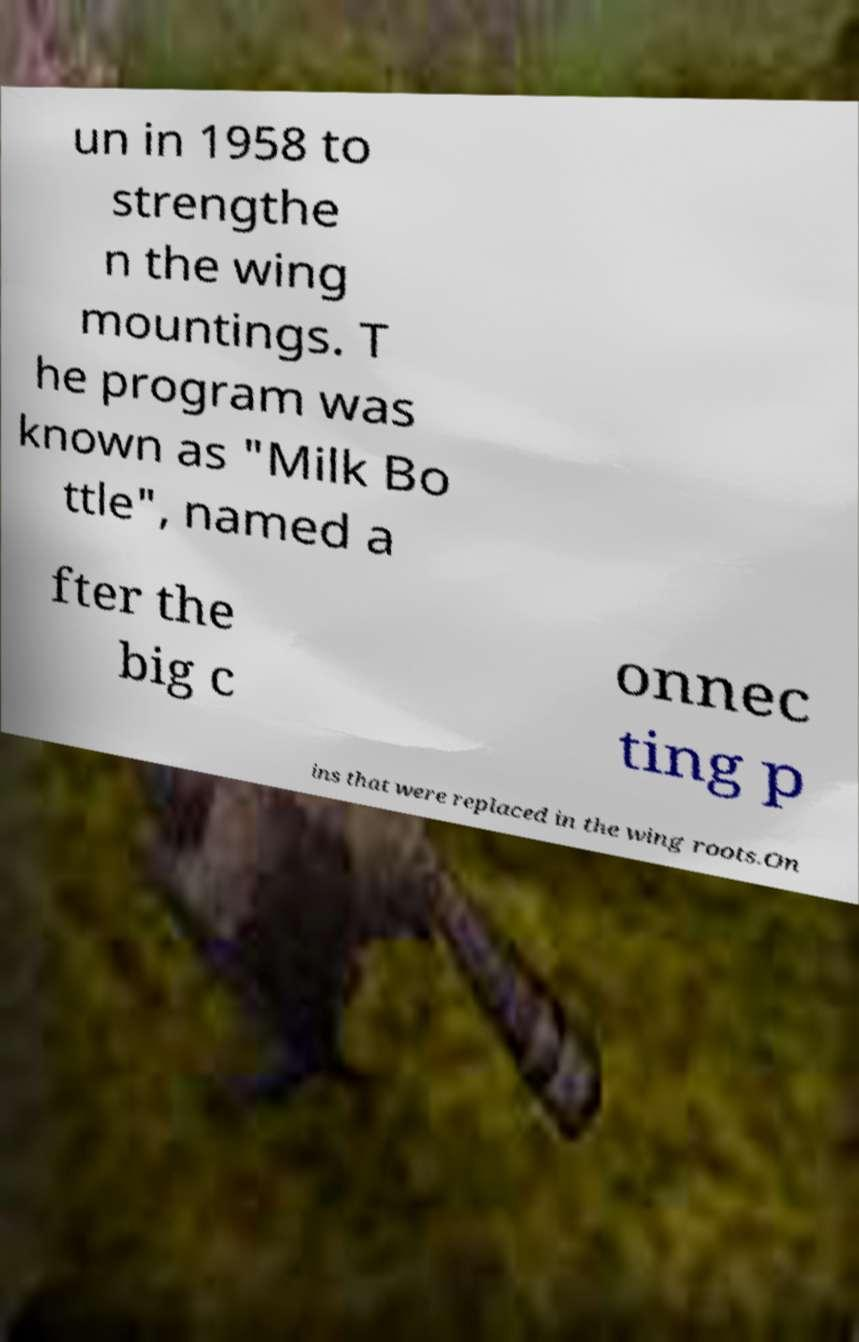Please identify and transcribe the text found in this image. un in 1958 to strengthe n the wing mountings. T he program was known as "Milk Bo ttle", named a fter the big c onnec ting p ins that were replaced in the wing roots.On 